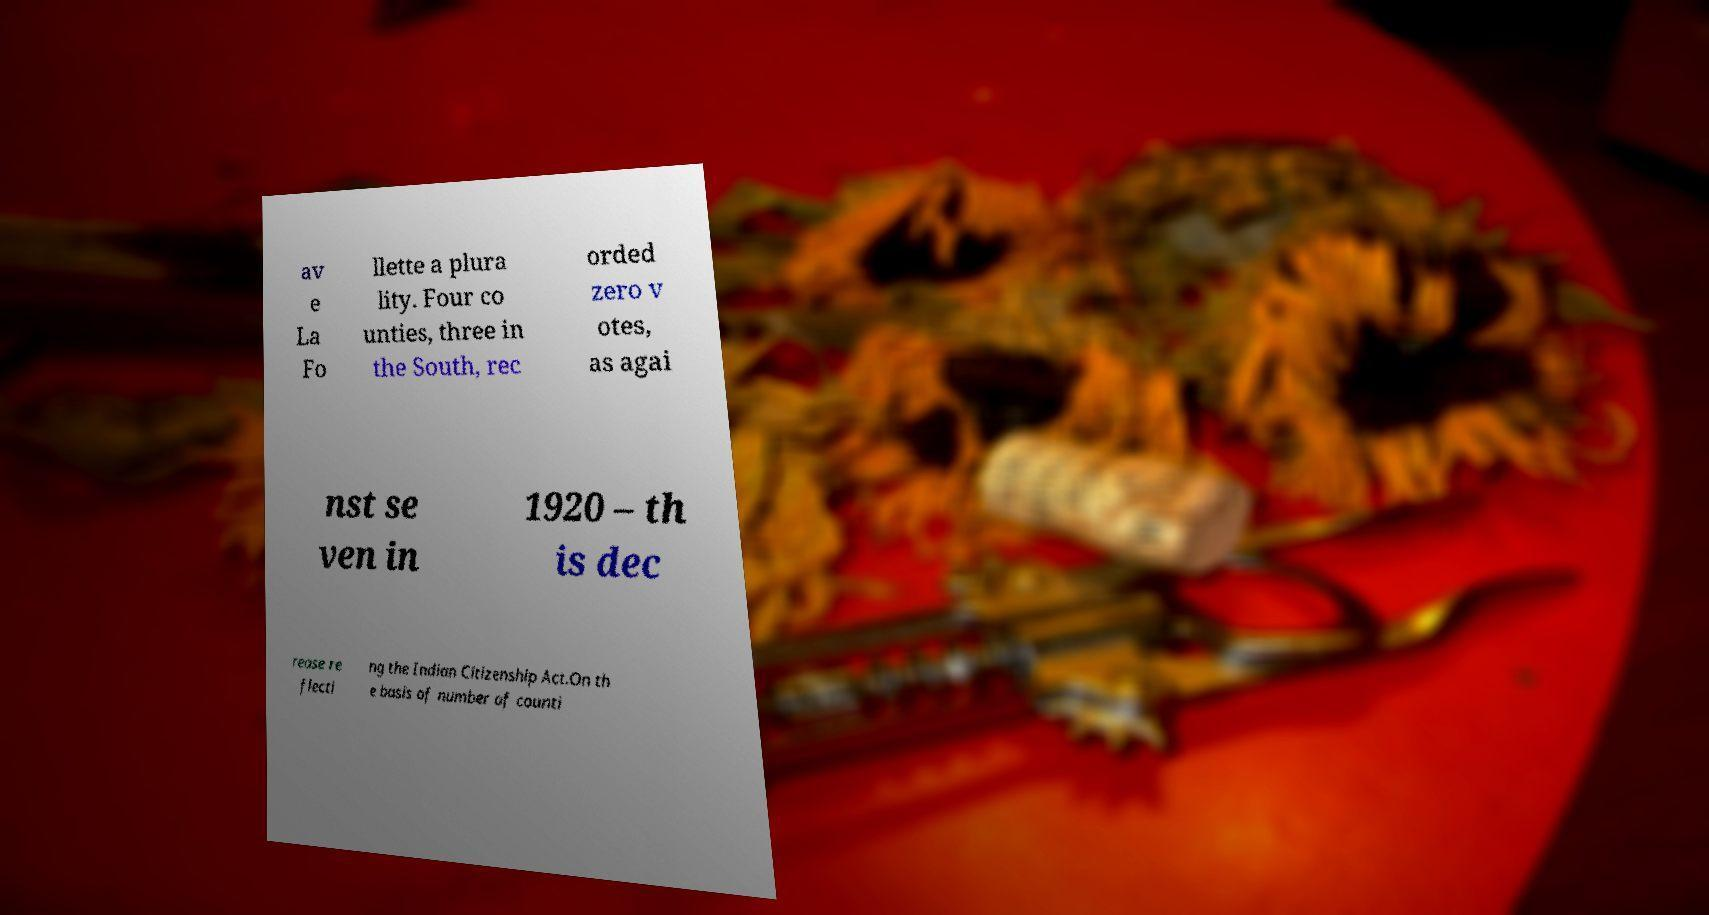Can you read and provide the text displayed in the image?This photo seems to have some interesting text. Can you extract and type it out for me? av e La Fo llette a plura lity. Four co unties, three in the South, rec orded zero v otes, as agai nst se ven in 1920 – th is dec rease re flecti ng the Indian Citizenship Act.On th e basis of number of counti 